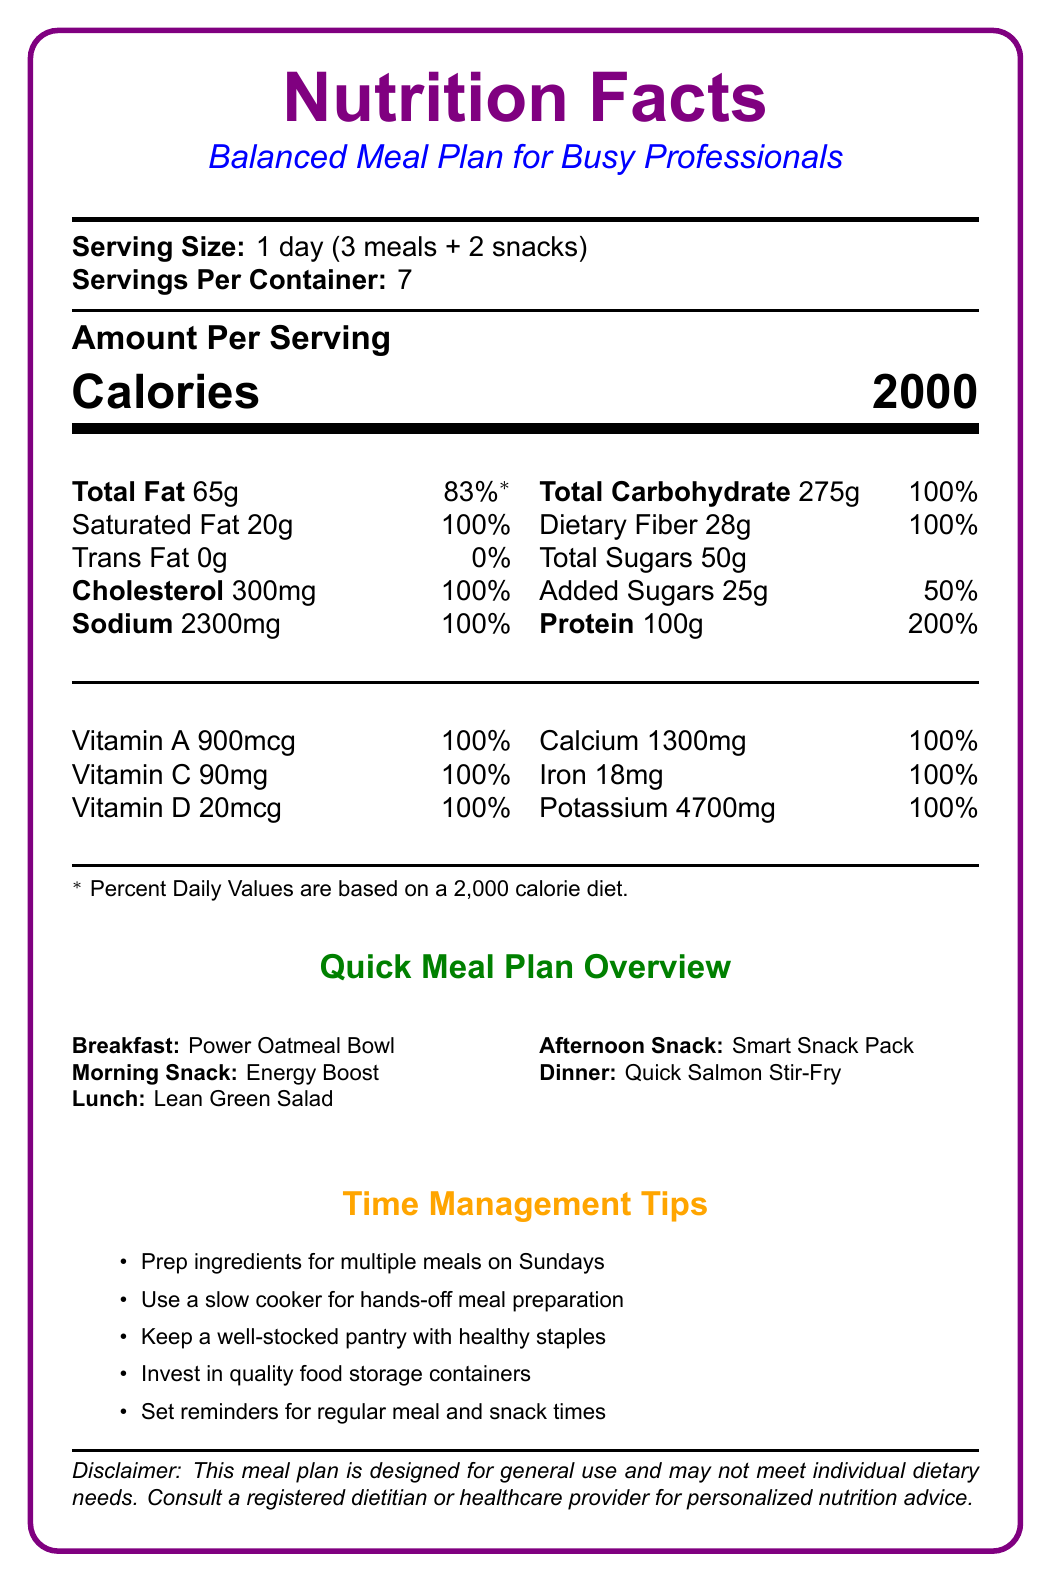what is the serving size of the meal plan? The serving size is mentioned right under the title "Serving Size".
Answer: 1 day (3 meals + 2 snacks) how many servings are in the container? The document lists "Servings Per Container: 7" below the serving size.
Answer: 7 how much total fat is in one serving? The total fat amount is provided in the nutritional information section as "Total Fat 65g".
Answer: 65g what percentage of the daily value of cholesterol does this meal plan provide? The document states "Cholesterol 300mg" which corresponds to 100% of the daily value.
Answer: 100% how many grams of protein are in one serving? The amount of protein per serving is listed as "Protein 100g".
Answer: 100g which of these nutrients has the highest daily value percentage? A. Total Carbohydrate B. Sodium C. Protein D. Total Sugars Protein has the highest daily value percentage at 200%, as indicated in the nutritional information.
Answer: C. Protein what color is used for the total carbohydrate section? A. Orange B. Green C. Blue D. Pink Each nutrient section has a color, and the color for "Total Carbohydrate" is labeled as "#1E90FF", which is a shade of blue.
Answer: C. Blue does the document include a specific plan for morning snacks? The document specifies "Morning Snack: Energy Boost" including apple slices and peanut butter.
Answer: Yes describe the main idea of the document. The document focuses on offering a comprehensive and convenient meal plan, emphasizing balanced nutrition and efficiency in meal preparation.
Answer: The document provides a balanced meal plan for busy professionals, detailing the nutritional facts, meal components, and time management tips. It includes a detailed breakdown of nutrients by daily value percentages, color-coded sections for quick reference, and practical tips for meal preparation and nutrition. does this meal plan include any trans fat? The nutritional information lists "Trans Fat 0g", indicating that there is no trans fat in the meal plan.
Answer: No how much vitamin A is in this meal plan? The document lists the amount of Vitamin A under the vitamins and minerals section as "Vitamin A 900mcg".
Answer: 900mcg which meal has the longest preparation time? A. Breakfast B. Lunch C. Dinner D. Morning Snack The dinner, "Quick Salmon Stir-Fry", has a prep time of 15 minutes, which is the longest among the meals listed.
Answer: C. Dinner can you determine exact calorie breakdown per meal (breakfast, lunch, dinner, snacks) from the document? The document provides total daily calories but does not break down the specific calorie content for each meal or snack.
Answer: Not enough information what is the recommended strategy for morning snack preparation? The morning snack is "Energy Boost" and has a prep time listed as "2 minutes".
Answer: 2 minutes how often does the document recommend preparing ingredients for multiple meals? The time management tips suggest prepping ingredients for multiple meals on Sundays.
Answer: On Sundays 